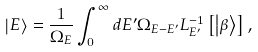<formula> <loc_0><loc_0><loc_500><loc_500>\left | E \right \rangle = \frac { 1 } { \Omega _ { E } } \int _ { 0 } ^ { \infty } d E ^ { \prime } \Omega _ { E - E ^ { \prime } } L _ { E ^ { \prime } } ^ { - 1 } \left [ \left | \beta \right \rangle \right ] ,</formula> 